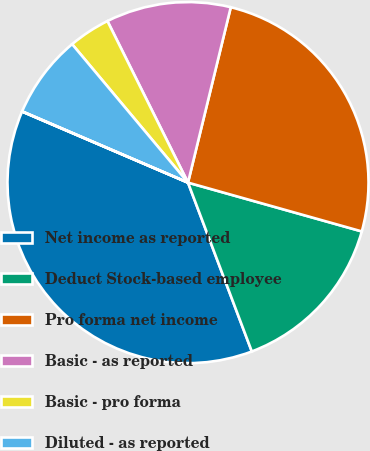Convert chart. <chart><loc_0><loc_0><loc_500><loc_500><pie_chart><fcel>Net income as reported<fcel>Deduct Stock-based employee<fcel>Pro forma net income<fcel>Basic - as reported<fcel>Basic - pro forma<fcel>Diluted - as reported<fcel>Diluted - pro forma<nl><fcel>37.19%<fcel>14.89%<fcel>25.55%<fcel>11.17%<fcel>3.73%<fcel>7.45%<fcel>0.02%<nl></chart> 